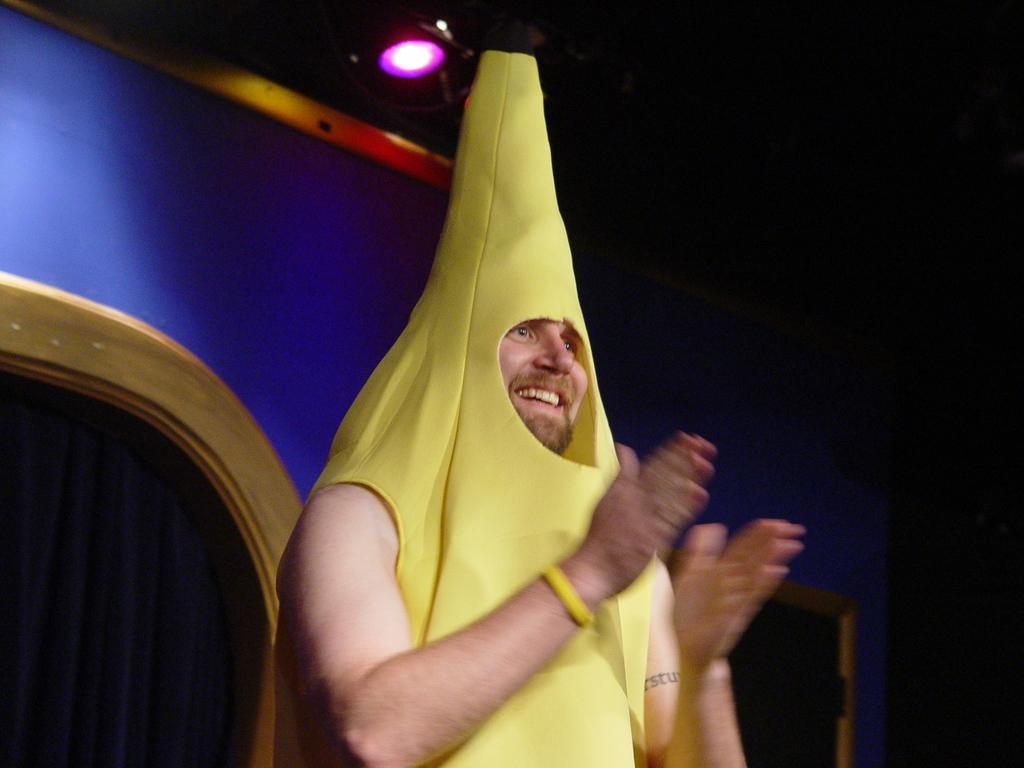Who is in the image? There is a person in the image. What is the person doing? The person is clapping. What can be seen in the background of the image? There is a wall in the background of the image. What is the source of light in the image? There is a light at the top of the image. What type of bread is being used to make a van in the image? There is no bread or van present in the image. What is the person's interest in the image? The provided facts do not mention the person's interests, so we cannot determine their interest from the image. 